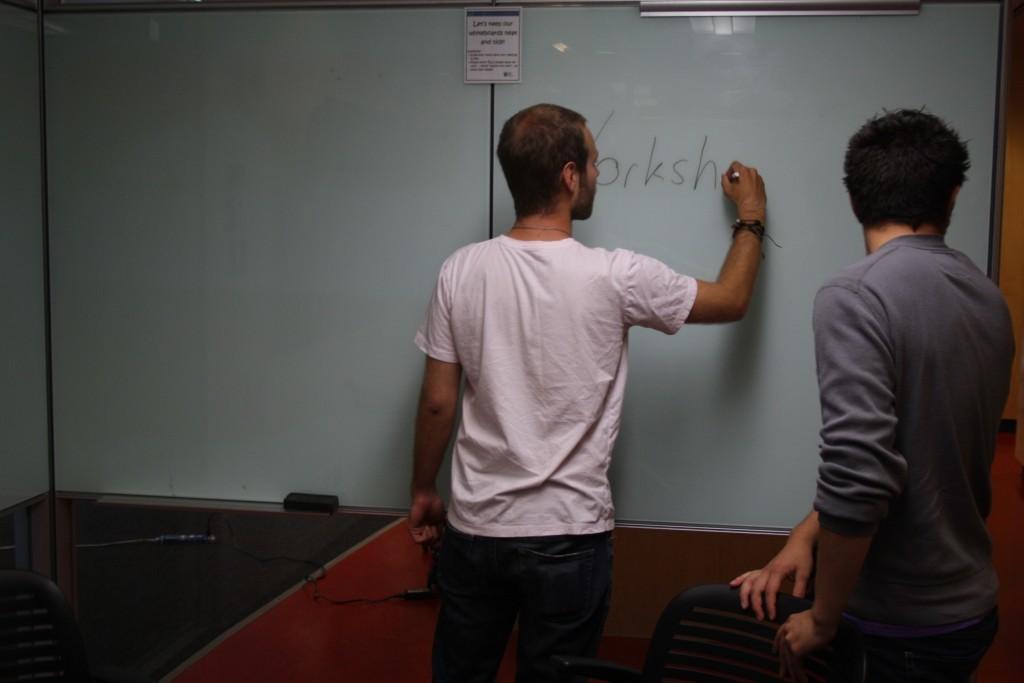What is being written?
Provide a succinct answer. Yorksh. White bord is there?
Your answer should be very brief. Answering does not require reading text in the image. 